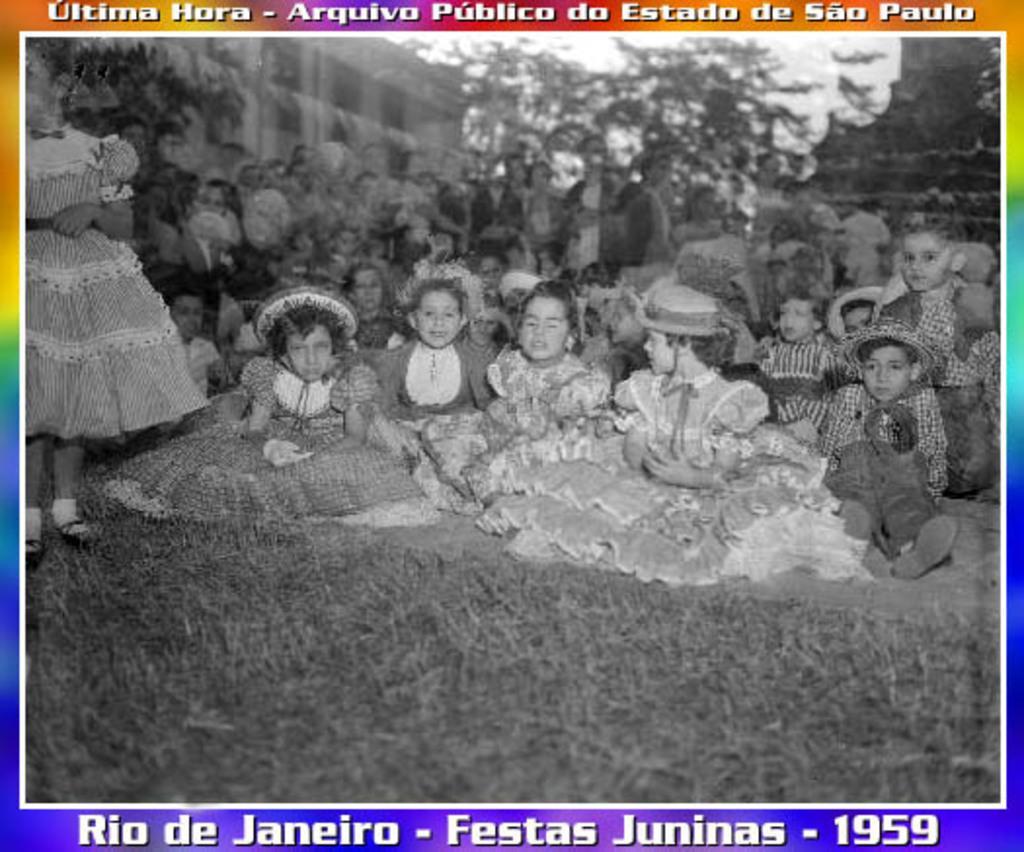Could you give a brief overview of what you see in this image? This is a black and white image and it is edited. In this image I can see the grass on the ground. In the middle of the image a crowd of children are sitting on the ground and few people are standing. In the background there are trees and a building. At the top and bottom of the image I can see some text. 